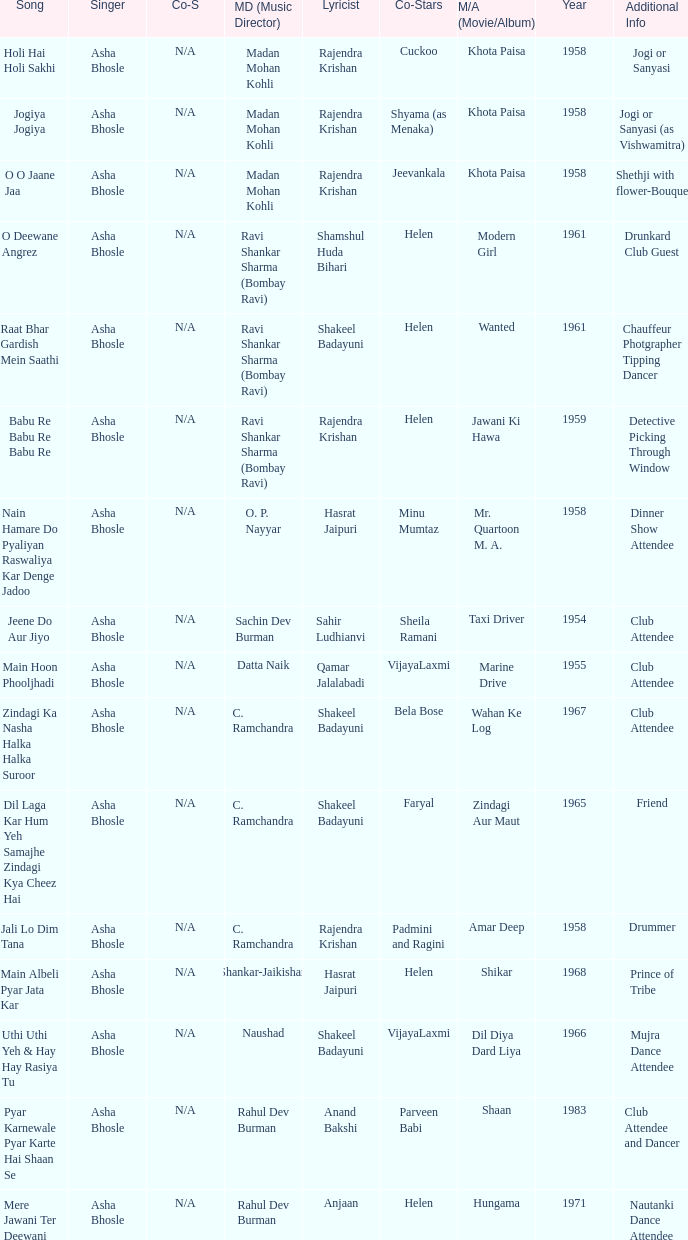What year did Naushad Direct the Music? 1966.0. 